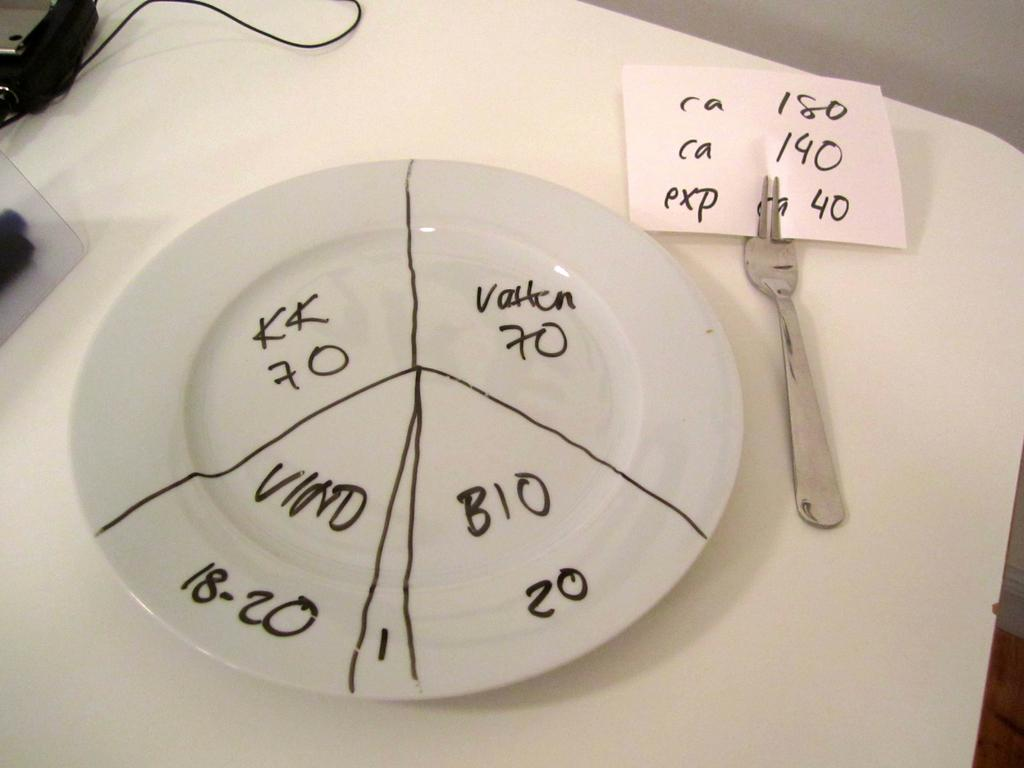What is the main object in the center of the image? There is a table in the center of the image. What is placed on the table? There is a plate, a fork, a paper, and a wire on the table. What is written on the paper? There is writing on the paper. Are there any other objects on the table? Yes, there are other objects on the table. How many pumpkins are on the table in the image? There is no mention of pumpkins in the image, so it is impossible to determine their presence or quantity. What type of bird can be seen flying over the table in the image? There is no bird present in the image, so it is impossible to determine its type or behavior. 